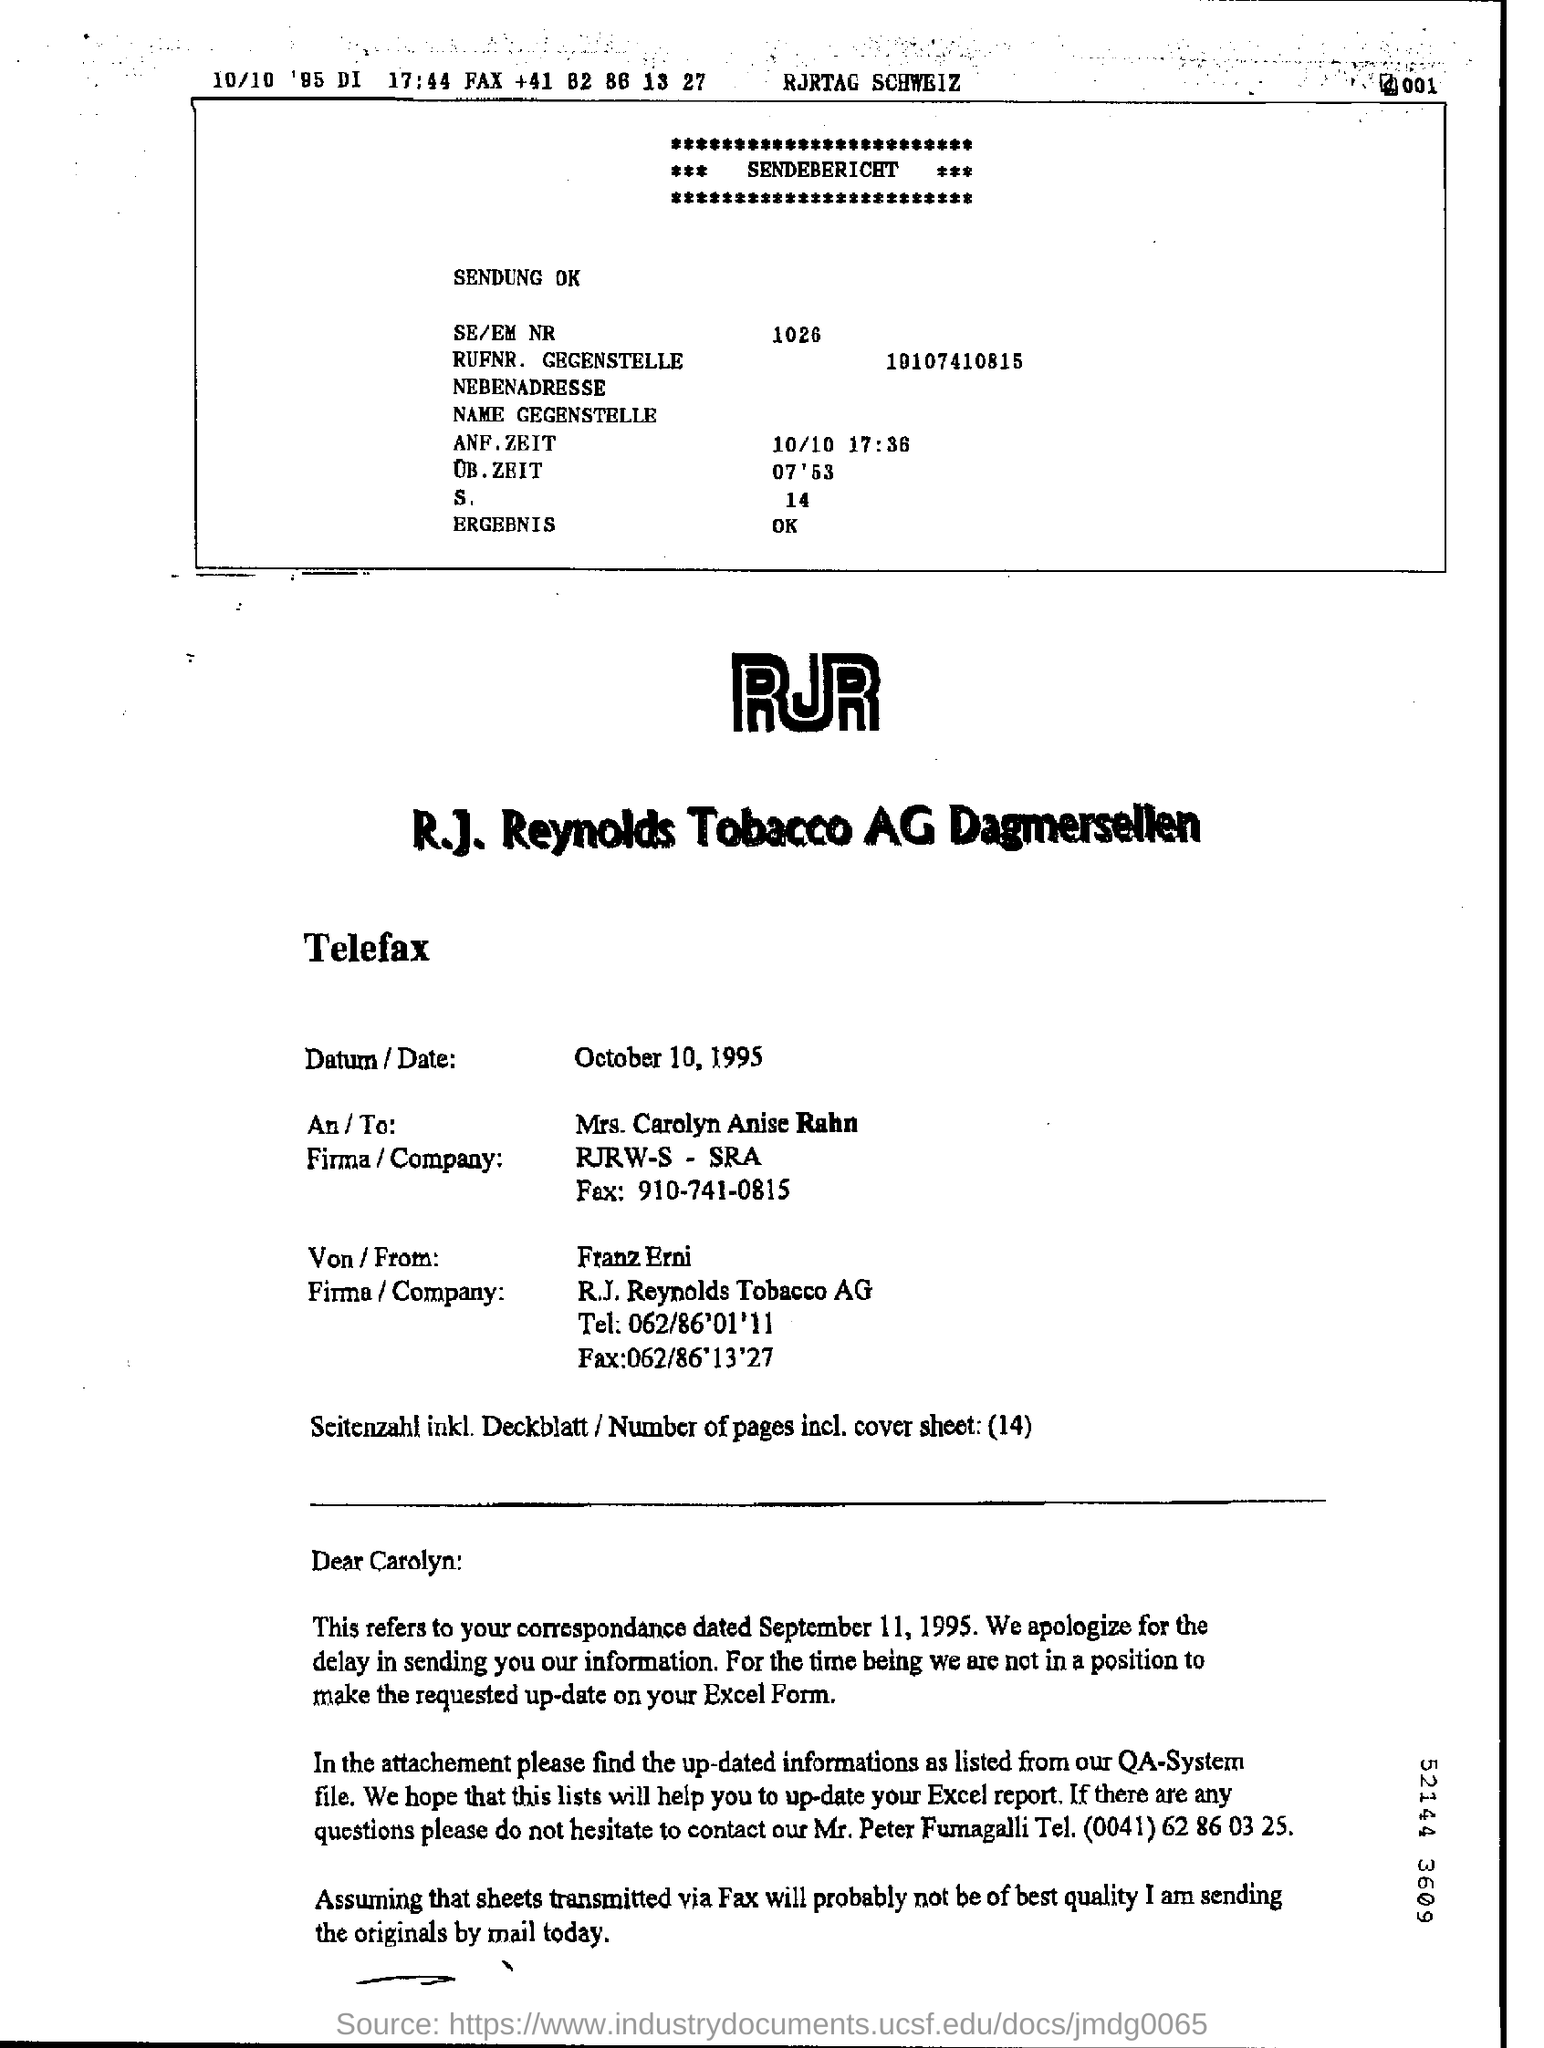What is the date in the Telefax?
Your answer should be compact. OCTOBER 10,1995. What is the company name of the mrs. carolyn anise rahn ?
Your answer should be compact. RJRW-S -SRA. 